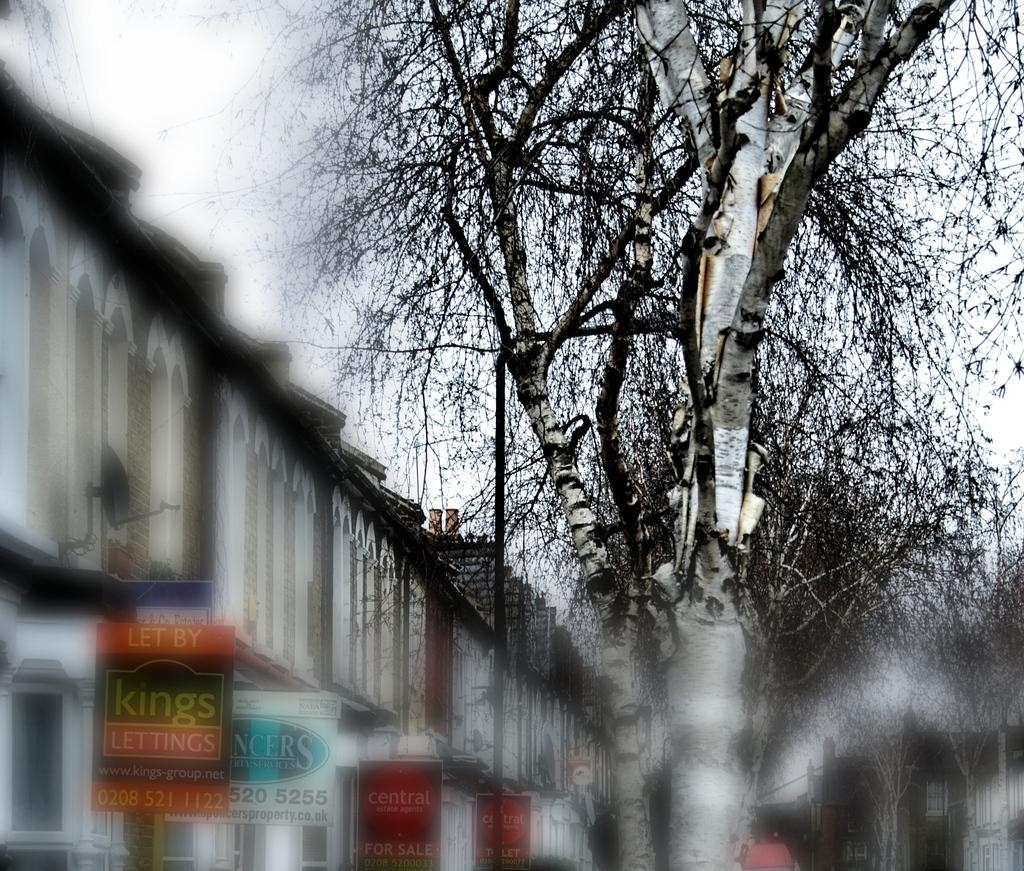<image>
Provide a brief description of the given image. A row of buildings with a sign that says "Let by Kings lettings" 